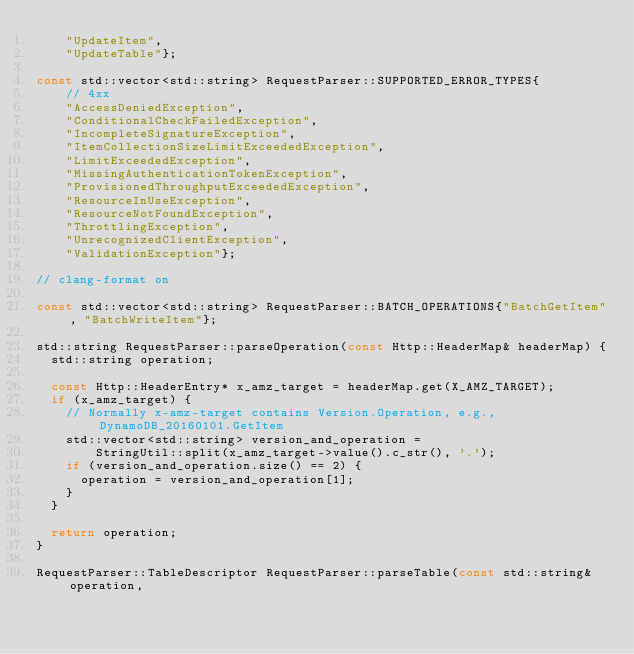Convert code to text. <code><loc_0><loc_0><loc_500><loc_500><_C++_>    "UpdateItem",
    "UpdateTable"};

const std::vector<std::string> RequestParser::SUPPORTED_ERROR_TYPES{
    // 4xx
    "AccessDeniedException",
    "ConditionalCheckFailedException",
    "IncompleteSignatureException",
    "ItemCollectionSizeLimitExceededException",
    "LimitExceededException",
    "MissingAuthenticationTokenException",
    "ProvisionedThroughputExceededException",
    "ResourceInUseException",
    "ResourceNotFoundException",
    "ThrottlingException",
    "UnrecognizedClientException",
    "ValidationException"};

// clang-format on

const std::vector<std::string> RequestParser::BATCH_OPERATIONS{"BatchGetItem", "BatchWriteItem"};

std::string RequestParser::parseOperation(const Http::HeaderMap& headerMap) {
  std::string operation;

  const Http::HeaderEntry* x_amz_target = headerMap.get(X_AMZ_TARGET);
  if (x_amz_target) {
    // Normally x-amz-target contains Version.Operation, e.g., DynamoDB_20160101.GetItem
    std::vector<std::string> version_and_operation =
        StringUtil::split(x_amz_target->value().c_str(), '.');
    if (version_and_operation.size() == 2) {
      operation = version_and_operation[1];
    }
  }

  return operation;
}

RequestParser::TableDescriptor RequestParser::parseTable(const std::string& operation,</code> 